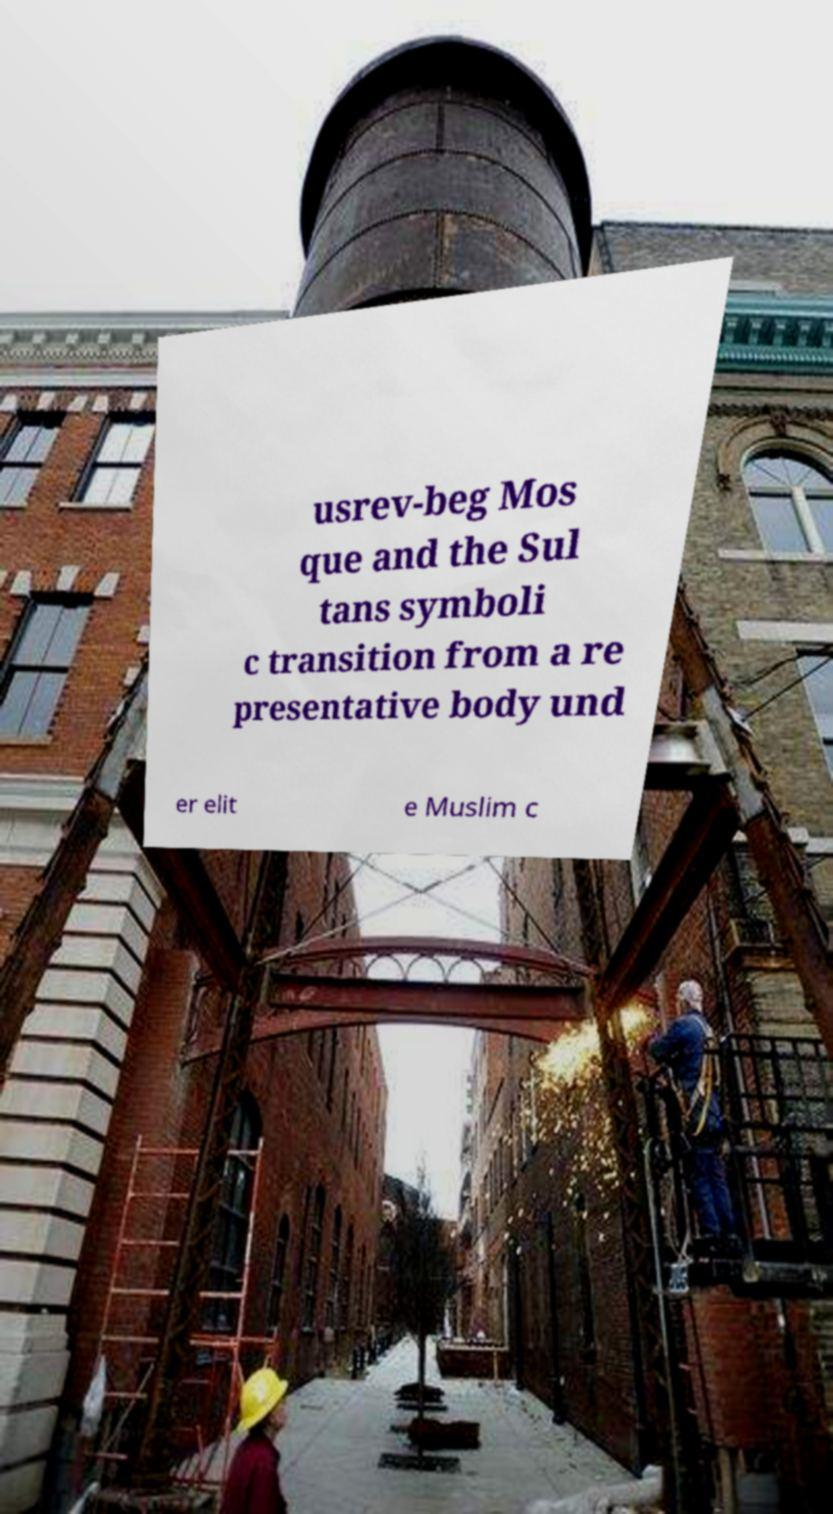What messages or text are displayed in this image? I need them in a readable, typed format. usrev-beg Mos que and the Sul tans symboli c transition from a re presentative body und er elit e Muslim c 